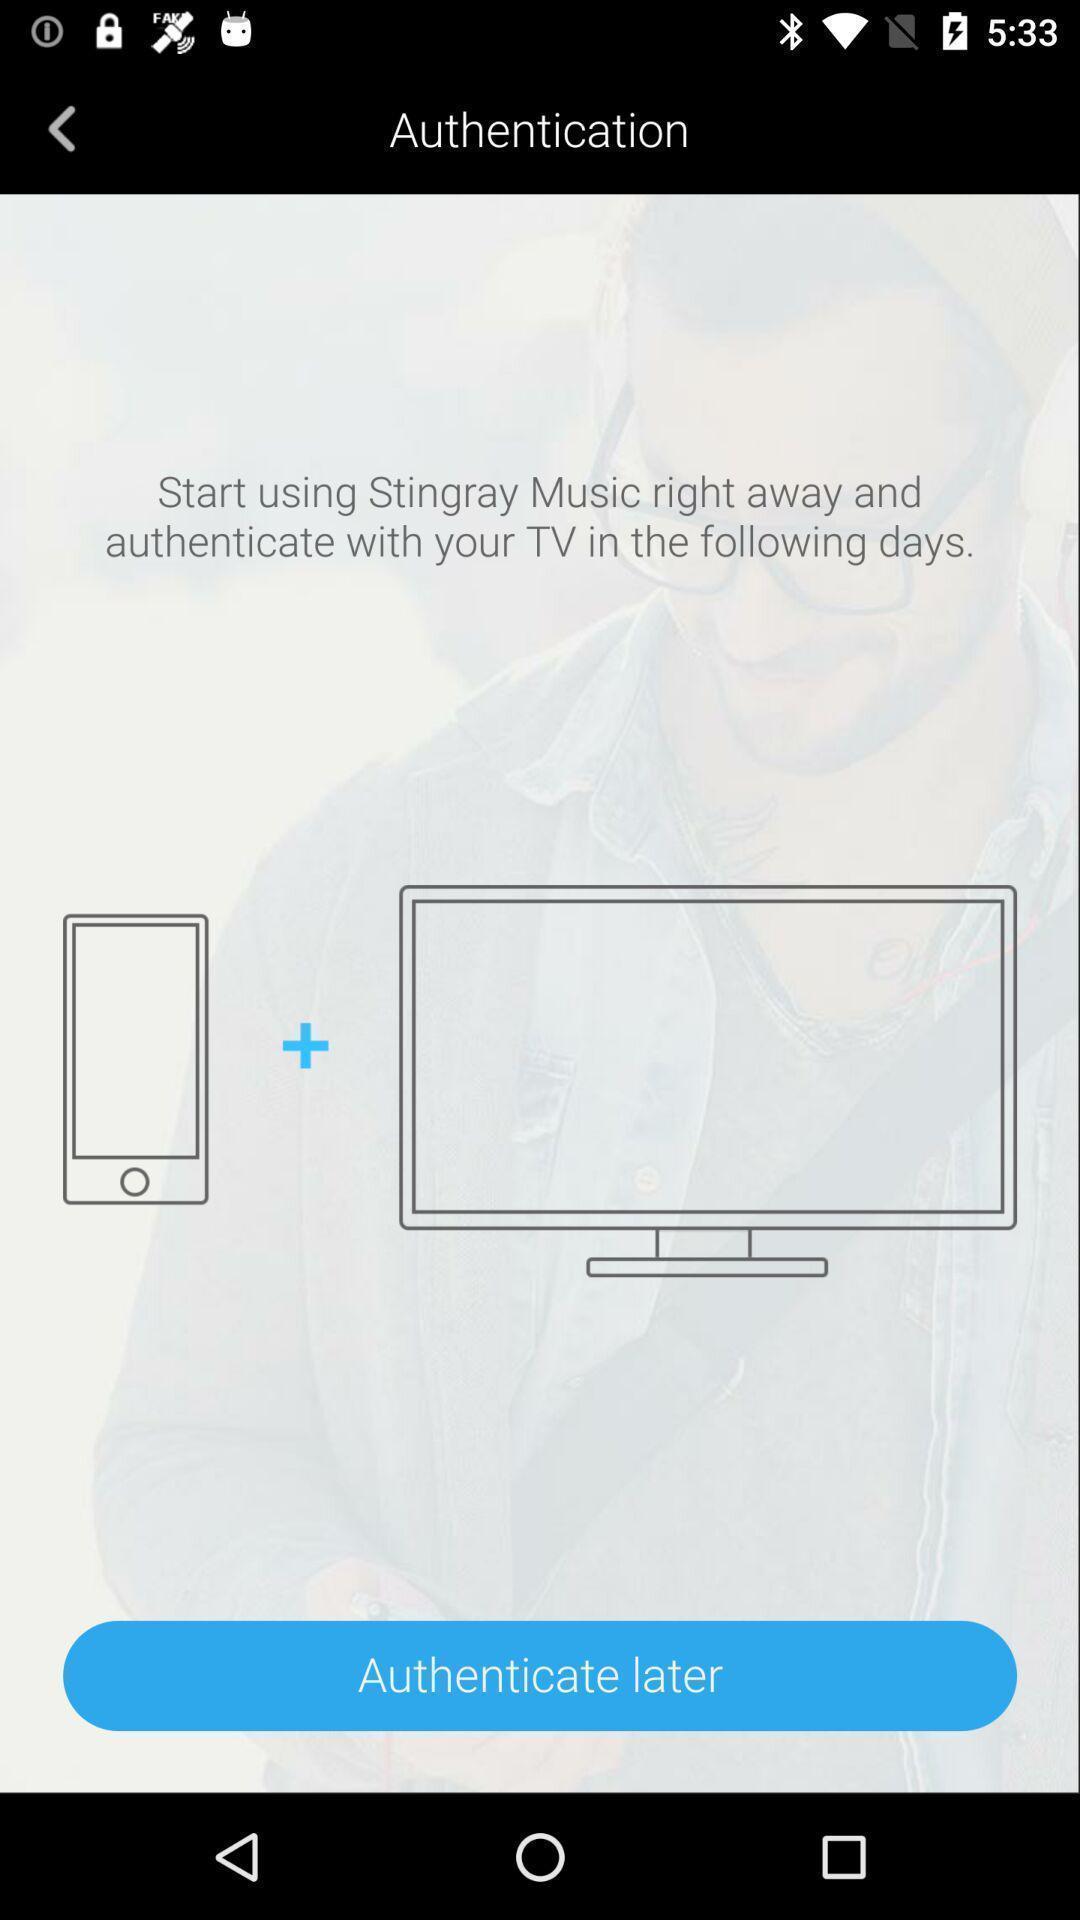Describe the key features of this screenshot. Screen displaying authentication an application. 